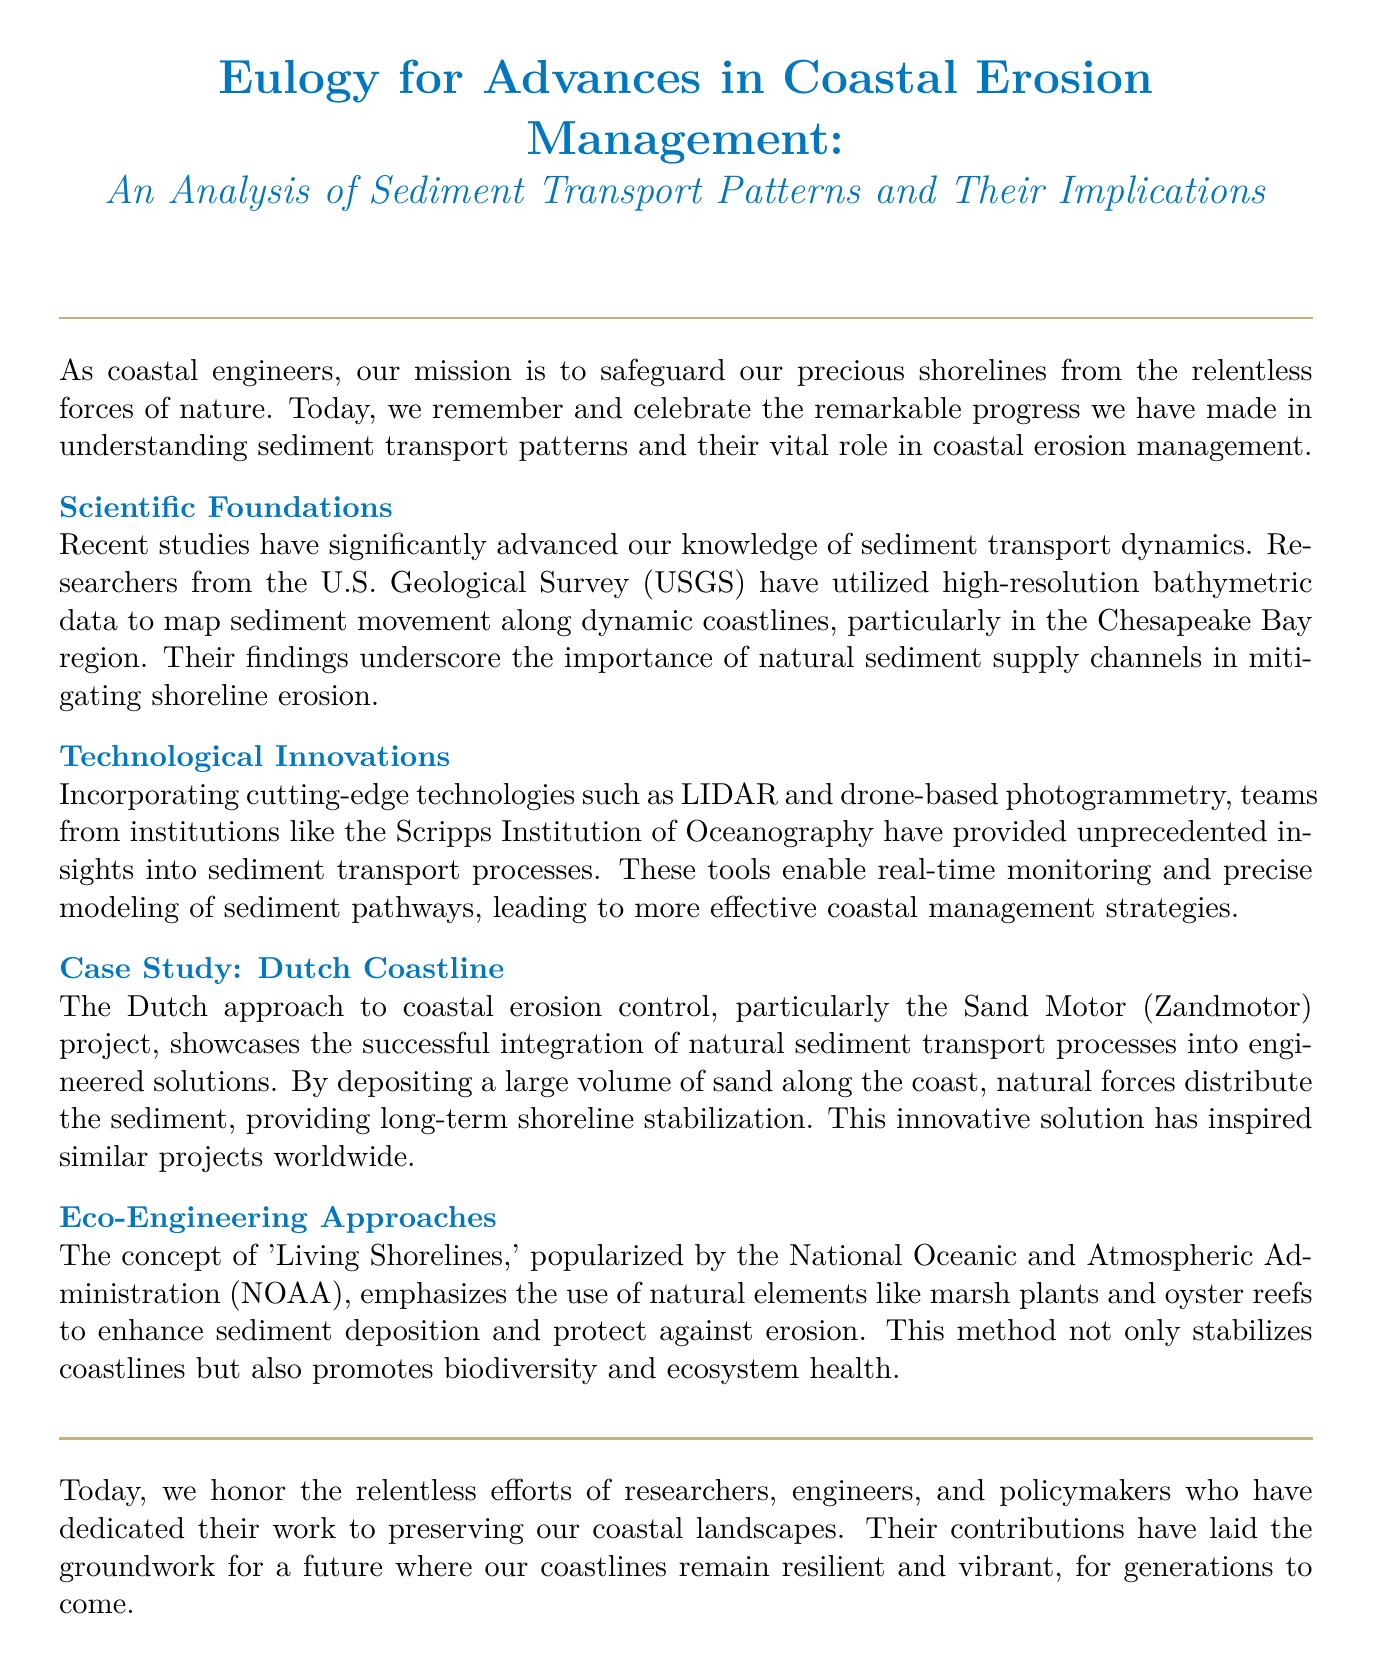What is the title of the document? The title is found at the beginning of the document, highlighting the focus on sediment transport patterns in coastal erosion management.
Answer: An Analysis of Sediment Transport Patterns and Their Implications Who conducted the recent studies on sediment transport dynamics? The document mentions the U.S. Geological Survey (USGS) as the research institution involved in the studies.
Answer: U.S. Geological Survey What innovative technologies are mentioned in the document? The technologies highlighted include LIDAR and drone-based photogrammetry, which aid in sediment transport monitoring.
Answer: LIDAR and drone-based photogrammetry Which coastal region is specifically mentioned for mapping sediment movement? The Chesapeake Bay region is identified as the area where sediment movement has been studied in detail.
Answer: Chesapeake Bay What is the name of the Dutch coastal erosion control project discussed? The project that integrates natural processes into engineered solutions is referred to as the Sand Motor (Zandmotor).
Answer: Sand Motor What concept emphasizes using natural elements for coastal protection? 'Living Shorelines' is the concept mentioned that promotes the use of natural elements to enhance sediment deposition.
Answer: Living Shorelines How do 'Living Shorelines' contribute to coastal management? The document highlights that this approach not only stabilizes coastlines but also promotes biodiversity and ecosystem health.
Answer: Biodiversity and ecosystem health What type of approach is showcased through the Dutch coastline case study? The document showcases an eco-engineering approach that combines natural processes with engineering solutions.
Answer: Eco-engineering approach Why do we honor researchers, engineers, and policymakers in this document? They are honored for their dedication to preserving coastal landscapes and contributing to erosion management strategies.
Answer: Preserving coastal landscapes 